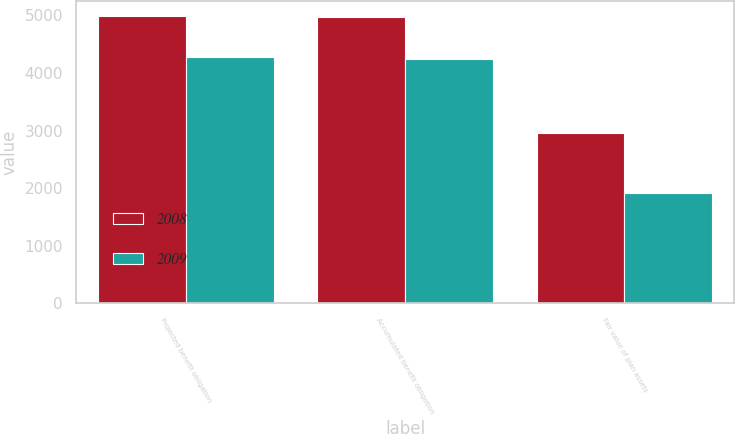Convert chart. <chart><loc_0><loc_0><loc_500><loc_500><stacked_bar_chart><ecel><fcel>Projected benefit obligation<fcel>Accumulated benefit obligation<fcel>Fair value of plan assets<nl><fcel>2008<fcel>4995<fcel>4963<fcel>2962<nl><fcel>2009<fcel>4274<fcel>4249<fcel>1908<nl></chart> 